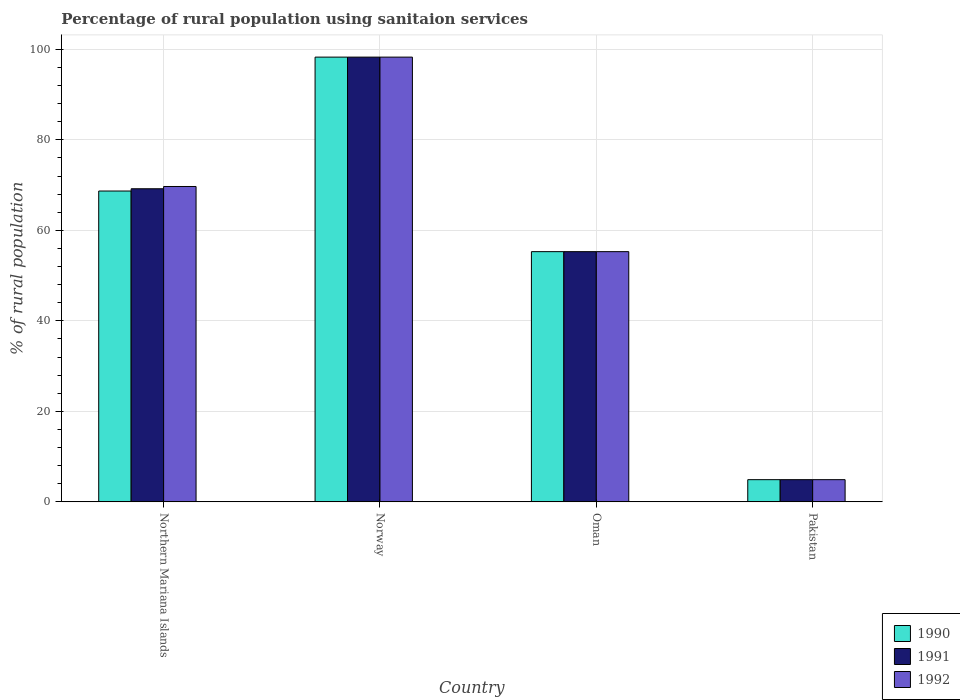How many different coloured bars are there?
Provide a succinct answer. 3. Are the number of bars per tick equal to the number of legend labels?
Your answer should be compact. Yes. What is the label of the 2nd group of bars from the left?
Provide a succinct answer. Norway. In how many cases, is the number of bars for a given country not equal to the number of legend labels?
Offer a very short reply. 0. What is the percentage of rural population using sanitaion services in 1992 in Norway?
Your answer should be compact. 98.3. Across all countries, what is the maximum percentage of rural population using sanitaion services in 1992?
Your answer should be compact. 98.3. Across all countries, what is the minimum percentage of rural population using sanitaion services in 1992?
Your answer should be very brief. 4.9. In which country was the percentage of rural population using sanitaion services in 1992 maximum?
Your answer should be compact. Norway. In which country was the percentage of rural population using sanitaion services in 1991 minimum?
Offer a very short reply. Pakistan. What is the total percentage of rural population using sanitaion services in 1991 in the graph?
Offer a terse response. 227.7. What is the difference between the percentage of rural population using sanitaion services in 1990 in Norway and that in Pakistan?
Your answer should be compact. 93.4. What is the difference between the percentage of rural population using sanitaion services in 1991 in Norway and the percentage of rural population using sanitaion services in 1992 in Oman?
Provide a succinct answer. 43. What is the average percentage of rural population using sanitaion services in 1990 per country?
Offer a very short reply. 56.8. What is the difference between the percentage of rural population using sanitaion services of/in 1991 and percentage of rural population using sanitaion services of/in 1990 in Norway?
Ensure brevity in your answer.  0. What is the ratio of the percentage of rural population using sanitaion services in 1992 in Norway to that in Oman?
Ensure brevity in your answer.  1.78. Is the percentage of rural population using sanitaion services in 1992 in Oman less than that in Pakistan?
Ensure brevity in your answer.  No. Is the difference between the percentage of rural population using sanitaion services in 1991 in Norway and Oman greater than the difference between the percentage of rural population using sanitaion services in 1990 in Norway and Oman?
Keep it short and to the point. No. What is the difference between the highest and the second highest percentage of rural population using sanitaion services in 1991?
Offer a very short reply. 29.1. What is the difference between the highest and the lowest percentage of rural population using sanitaion services in 1990?
Your answer should be compact. 93.4. What does the 1st bar from the left in Oman represents?
Keep it short and to the point. 1990. Is it the case that in every country, the sum of the percentage of rural population using sanitaion services in 1991 and percentage of rural population using sanitaion services in 1990 is greater than the percentage of rural population using sanitaion services in 1992?
Offer a terse response. Yes. What is the difference between two consecutive major ticks on the Y-axis?
Offer a terse response. 20. Are the values on the major ticks of Y-axis written in scientific E-notation?
Provide a short and direct response. No. Does the graph contain grids?
Provide a succinct answer. Yes. How many legend labels are there?
Your answer should be compact. 3. How are the legend labels stacked?
Keep it short and to the point. Vertical. What is the title of the graph?
Offer a very short reply. Percentage of rural population using sanitaion services. Does "1979" appear as one of the legend labels in the graph?
Offer a very short reply. No. What is the label or title of the X-axis?
Ensure brevity in your answer.  Country. What is the label or title of the Y-axis?
Give a very brief answer. % of rural population. What is the % of rural population of 1990 in Northern Mariana Islands?
Provide a succinct answer. 68.7. What is the % of rural population of 1991 in Northern Mariana Islands?
Provide a succinct answer. 69.2. What is the % of rural population in 1992 in Northern Mariana Islands?
Provide a short and direct response. 69.7. What is the % of rural population in 1990 in Norway?
Your answer should be compact. 98.3. What is the % of rural population in 1991 in Norway?
Provide a short and direct response. 98.3. What is the % of rural population in 1992 in Norway?
Provide a short and direct response. 98.3. What is the % of rural population in 1990 in Oman?
Keep it short and to the point. 55.3. What is the % of rural population of 1991 in Oman?
Offer a very short reply. 55.3. What is the % of rural population in 1992 in Oman?
Your answer should be compact. 55.3. Across all countries, what is the maximum % of rural population of 1990?
Ensure brevity in your answer.  98.3. Across all countries, what is the maximum % of rural population of 1991?
Your answer should be compact. 98.3. Across all countries, what is the maximum % of rural population in 1992?
Offer a very short reply. 98.3. Across all countries, what is the minimum % of rural population in 1990?
Keep it short and to the point. 4.9. What is the total % of rural population of 1990 in the graph?
Your answer should be very brief. 227.2. What is the total % of rural population in 1991 in the graph?
Your answer should be compact. 227.7. What is the total % of rural population in 1992 in the graph?
Make the answer very short. 228.2. What is the difference between the % of rural population of 1990 in Northern Mariana Islands and that in Norway?
Your response must be concise. -29.6. What is the difference between the % of rural population of 1991 in Northern Mariana Islands and that in Norway?
Your answer should be very brief. -29.1. What is the difference between the % of rural population of 1992 in Northern Mariana Islands and that in Norway?
Make the answer very short. -28.6. What is the difference between the % of rural population of 1992 in Northern Mariana Islands and that in Oman?
Provide a succinct answer. 14.4. What is the difference between the % of rural population of 1990 in Northern Mariana Islands and that in Pakistan?
Make the answer very short. 63.8. What is the difference between the % of rural population of 1991 in Northern Mariana Islands and that in Pakistan?
Provide a short and direct response. 64.3. What is the difference between the % of rural population of 1992 in Northern Mariana Islands and that in Pakistan?
Offer a terse response. 64.8. What is the difference between the % of rural population in 1990 in Norway and that in Oman?
Keep it short and to the point. 43. What is the difference between the % of rural population of 1992 in Norway and that in Oman?
Provide a succinct answer. 43. What is the difference between the % of rural population of 1990 in Norway and that in Pakistan?
Offer a terse response. 93.4. What is the difference between the % of rural population in 1991 in Norway and that in Pakistan?
Give a very brief answer. 93.4. What is the difference between the % of rural population in 1992 in Norway and that in Pakistan?
Your answer should be very brief. 93.4. What is the difference between the % of rural population of 1990 in Oman and that in Pakistan?
Offer a terse response. 50.4. What is the difference between the % of rural population in 1991 in Oman and that in Pakistan?
Provide a succinct answer. 50.4. What is the difference between the % of rural population in 1992 in Oman and that in Pakistan?
Make the answer very short. 50.4. What is the difference between the % of rural population of 1990 in Northern Mariana Islands and the % of rural population of 1991 in Norway?
Provide a succinct answer. -29.6. What is the difference between the % of rural population in 1990 in Northern Mariana Islands and the % of rural population in 1992 in Norway?
Your response must be concise. -29.6. What is the difference between the % of rural population of 1991 in Northern Mariana Islands and the % of rural population of 1992 in Norway?
Provide a short and direct response. -29.1. What is the difference between the % of rural population in 1990 in Northern Mariana Islands and the % of rural population in 1991 in Pakistan?
Keep it short and to the point. 63.8. What is the difference between the % of rural population in 1990 in Northern Mariana Islands and the % of rural population in 1992 in Pakistan?
Your answer should be very brief. 63.8. What is the difference between the % of rural population in 1991 in Northern Mariana Islands and the % of rural population in 1992 in Pakistan?
Your response must be concise. 64.3. What is the difference between the % of rural population in 1990 in Norway and the % of rural population in 1992 in Oman?
Provide a short and direct response. 43. What is the difference between the % of rural population of 1990 in Norway and the % of rural population of 1991 in Pakistan?
Offer a very short reply. 93.4. What is the difference between the % of rural population of 1990 in Norway and the % of rural population of 1992 in Pakistan?
Ensure brevity in your answer.  93.4. What is the difference between the % of rural population in 1991 in Norway and the % of rural population in 1992 in Pakistan?
Offer a terse response. 93.4. What is the difference between the % of rural population in 1990 in Oman and the % of rural population in 1991 in Pakistan?
Your answer should be compact. 50.4. What is the difference between the % of rural population in 1990 in Oman and the % of rural population in 1992 in Pakistan?
Your response must be concise. 50.4. What is the difference between the % of rural population of 1991 in Oman and the % of rural population of 1992 in Pakistan?
Give a very brief answer. 50.4. What is the average % of rural population in 1990 per country?
Your answer should be compact. 56.8. What is the average % of rural population in 1991 per country?
Provide a short and direct response. 56.92. What is the average % of rural population of 1992 per country?
Make the answer very short. 57.05. What is the difference between the % of rural population in 1991 and % of rural population in 1992 in Northern Mariana Islands?
Your response must be concise. -0.5. What is the difference between the % of rural population of 1990 and % of rural population of 1991 in Norway?
Offer a very short reply. 0. What is the difference between the % of rural population in 1991 and % of rural population in 1992 in Norway?
Your answer should be compact. 0. What is the difference between the % of rural population of 1990 and % of rural population of 1991 in Oman?
Keep it short and to the point. 0. What is the difference between the % of rural population of 1990 and % of rural population of 1991 in Pakistan?
Your answer should be very brief. 0. What is the difference between the % of rural population of 1990 and % of rural population of 1992 in Pakistan?
Ensure brevity in your answer.  0. What is the ratio of the % of rural population in 1990 in Northern Mariana Islands to that in Norway?
Offer a very short reply. 0.7. What is the ratio of the % of rural population of 1991 in Northern Mariana Islands to that in Norway?
Give a very brief answer. 0.7. What is the ratio of the % of rural population in 1992 in Northern Mariana Islands to that in Norway?
Provide a succinct answer. 0.71. What is the ratio of the % of rural population of 1990 in Northern Mariana Islands to that in Oman?
Offer a terse response. 1.24. What is the ratio of the % of rural population of 1991 in Northern Mariana Islands to that in Oman?
Make the answer very short. 1.25. What is the ratio of the % of rural population of 1992 in Northern Mariana Islands to that in Oman?
Your answer should be very brief. 1.26. What is the ratio of the % of rural population of 1990 in Northern Mariana Islands to that in Pakistan?
Keep it short and to the point. 14.02. What is the ratio of the % of rural population of 1991 in Northern Mariana Islands to that in Pakistan?
Make the answer very short. 14.12. What is the ratio of the % of rural population in 1992 in Northern Mariana Islands to that in Pakistan?
Provide a succinct answer. 14.22. What is the ratio of the % of rural population of 1990 in Norway to that in Oman?
Make the answer very short. 1.78. What is the ratio of the % of rural population of 1991 in Norway to that in Oman?
Your answer should be very brief. 1.78. What is the ratio of the % of rural population in 1992 in Norway to that in Oman?
Provide a short and direct response. 1.78. What is the ratio of the % of rural population of 1990 in Norway to that in Pakistan?
Your answer should be very brief. 20.06. What is the ratio of the % of rural population in 1991 in Norway to that in Pakistan?
Your answer should be very brief. 20.06. What is the ratio of the % of rural population in 1992 in Norway to that in Pakistan?
Provide a succinct answer. 20.06. What is the ratio of the % of rural population in 1990 in Oman to that in Pakistan?
Provide a succinct answer. 11.29. What is the ratio of the % of rural population of 1991 in Oman to that in Pakistan?
Make the answer very short. 11.29. What is the ratio of the % of rural population in 1992 in Oman to that in Pakistan?
Keep it short and to the point. 11.29. What is the difference between the highest and the second highest % of rural population of 1990?
Provide a succinct answer. 29.6. What is the difference between the highest and the second highest % of rural population in 1991?
Provide a short and direct response. 29.1. What is the difference between the highest and the second highest % of rural population in 1992?
Your response must be concise. 28.6. What is the difference between the highest and the lowest % of rural population of 1990?
Provide a succinct answer. 93.4. What is the difference between the highest and the lowest % of rural population of 1991?
Offer a very short reply. 93.4. What is the difference between the highest and the lowest % of rural population of 1992?
Provide a short and direct response. 93.4. 